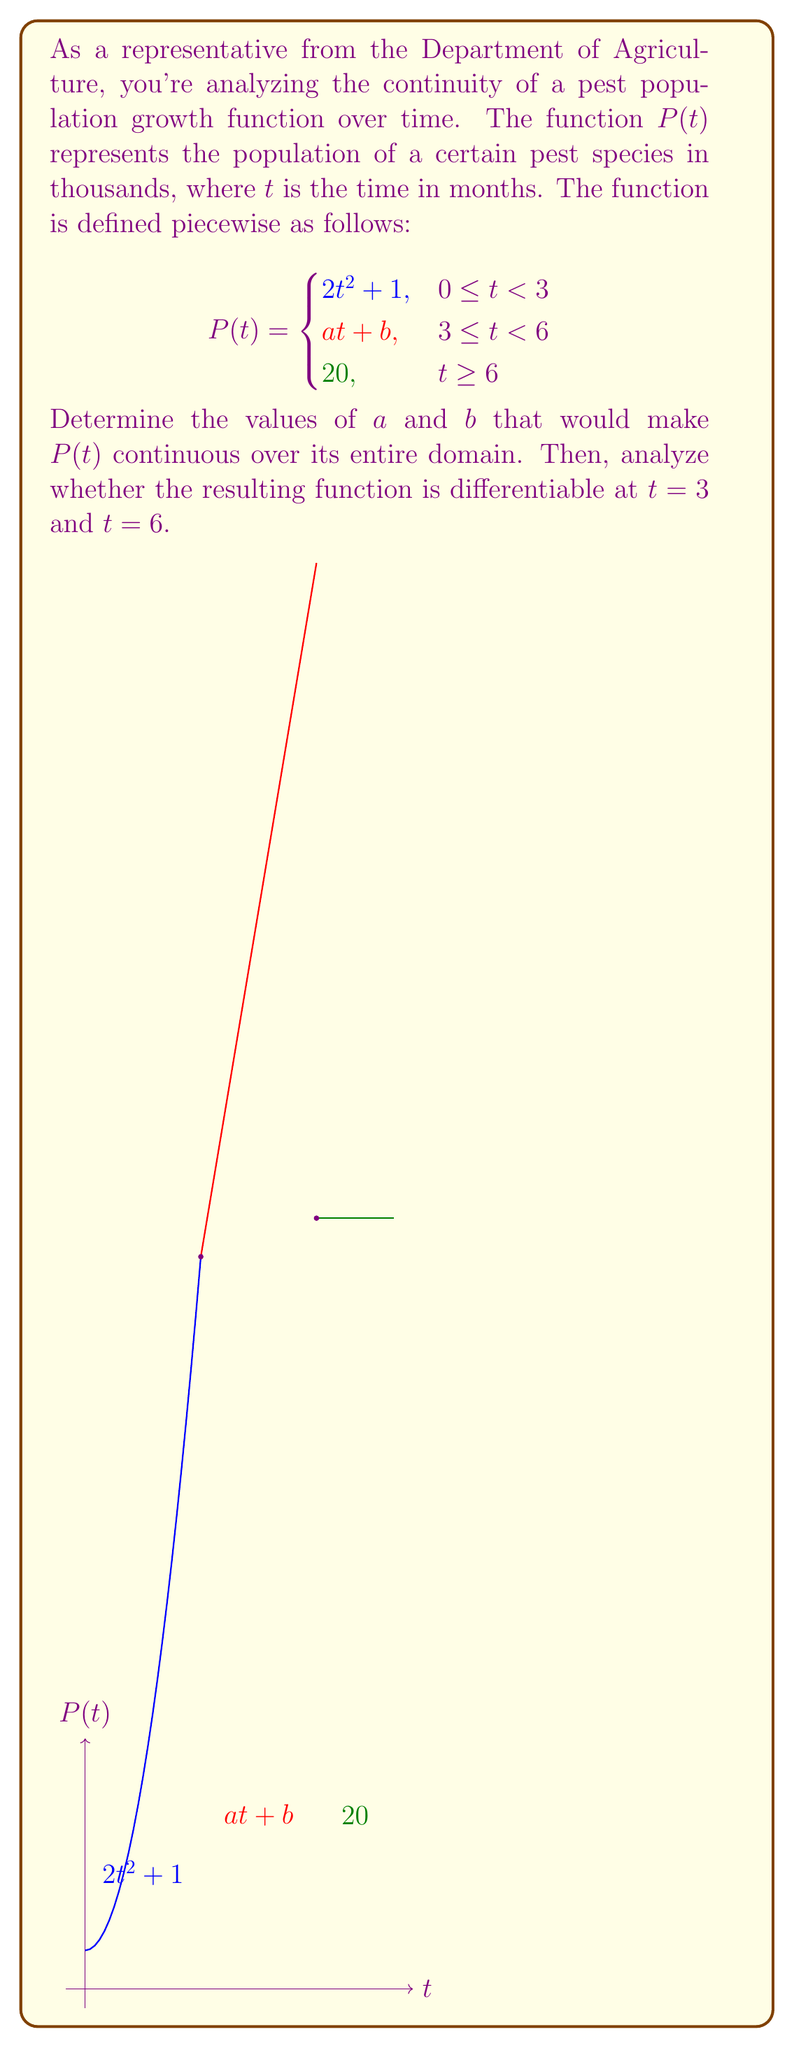What is the answer to this math problem? To make $P(t)$ continuous over its entire domain, we need to ensure that the function is continuous at $t = 3$ and $t = 6$.

Step 1: Continuity at $t = 3$
For continuity at $t = 3$, the limit of $P(t)$ as $t$ approaches 3 from both sides should equal $P(3)$.

Left-hand limit: $\lim_{t \to 3^-} P(t) = 2(3)^2 + 1 = 19$
Right-hand limit: $\lim_{t \to 3^+} P(t) = a(3) + b$

For continuity: $2(3)^2 + 1 = a(3) + b$
$19 = 3a + b$ ... (Equation 1)

Step 2: Continuity at $t = 6$
Similarly, for continuity at $t = 6$:

Left-hand limit: $\lim_{t \to 6^-} P(t) = a(6) + b$
Right-hand limit: $\lim_{t \to 6^+} P(t) = 20$

For continuity: $a(6) + b = 20$ ... (Equation 2)

Step 3: Solve the system of equations
From Equation 2: $b = 20 - 6a$
Substituting this into Equation 1:
$19 = 3a + (20 - 6a)$
$19 = 20 - 3a$
$3a = 1$
$a = \frac{1}{3}$

Substituting back:
$b = 20 - 6(\frac{1}{3}) = 18$

Step 4: Differentiability analysis
At $t = 3$:
Left-hand derivative: $\lim_{t \to 3^-} \frac{d}{dt}(2t^2 + 1) = 4t|_{t=3} = 12$
Right-hand derivative: $\lim_{t \to 3^+} \frac{d}{dt}(at + b) = a = \frac{1}{3}$

Since these derivatives are not equal, $P(t)$ is not differentiable at $t = 3$.

At $t = 6$:
Left-hand derivative: $\lim_{t \to 6^-} \frac{d}{dt}(at + b) = a = \frac{1}{3}$
Right-hand derivative: $\lim_{t \to 6^+} \frac{d}{dt}(20) = 0$

Since these derivatives are not equal, $P(t)$ is not differentiable at $t = 6$.
Answer: $a = \frac{1}{3}$, $b = 18$; $P(t)$ is continuous but not differentiable at $t = 3$ and $t = 6$. 